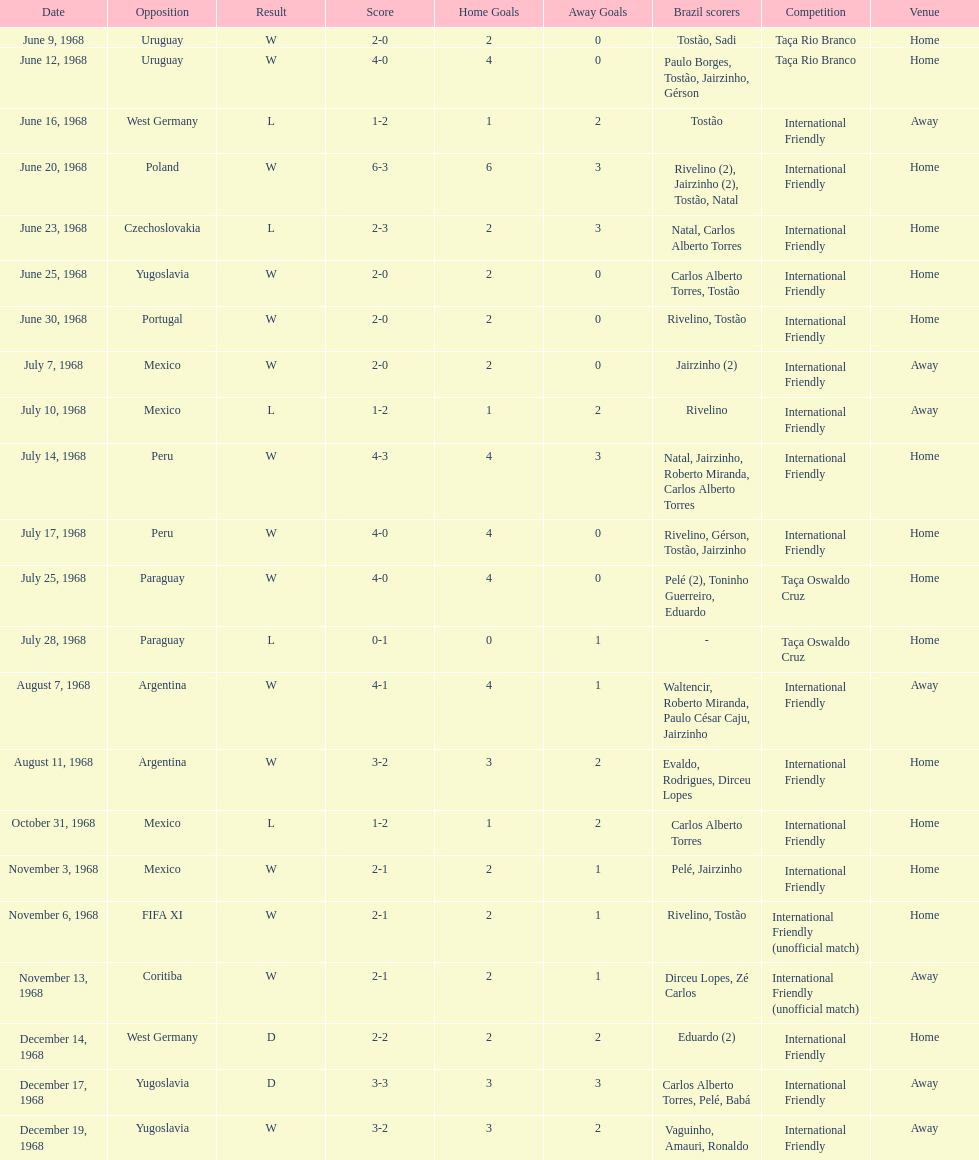Can you provide the amount of losses? 5. 